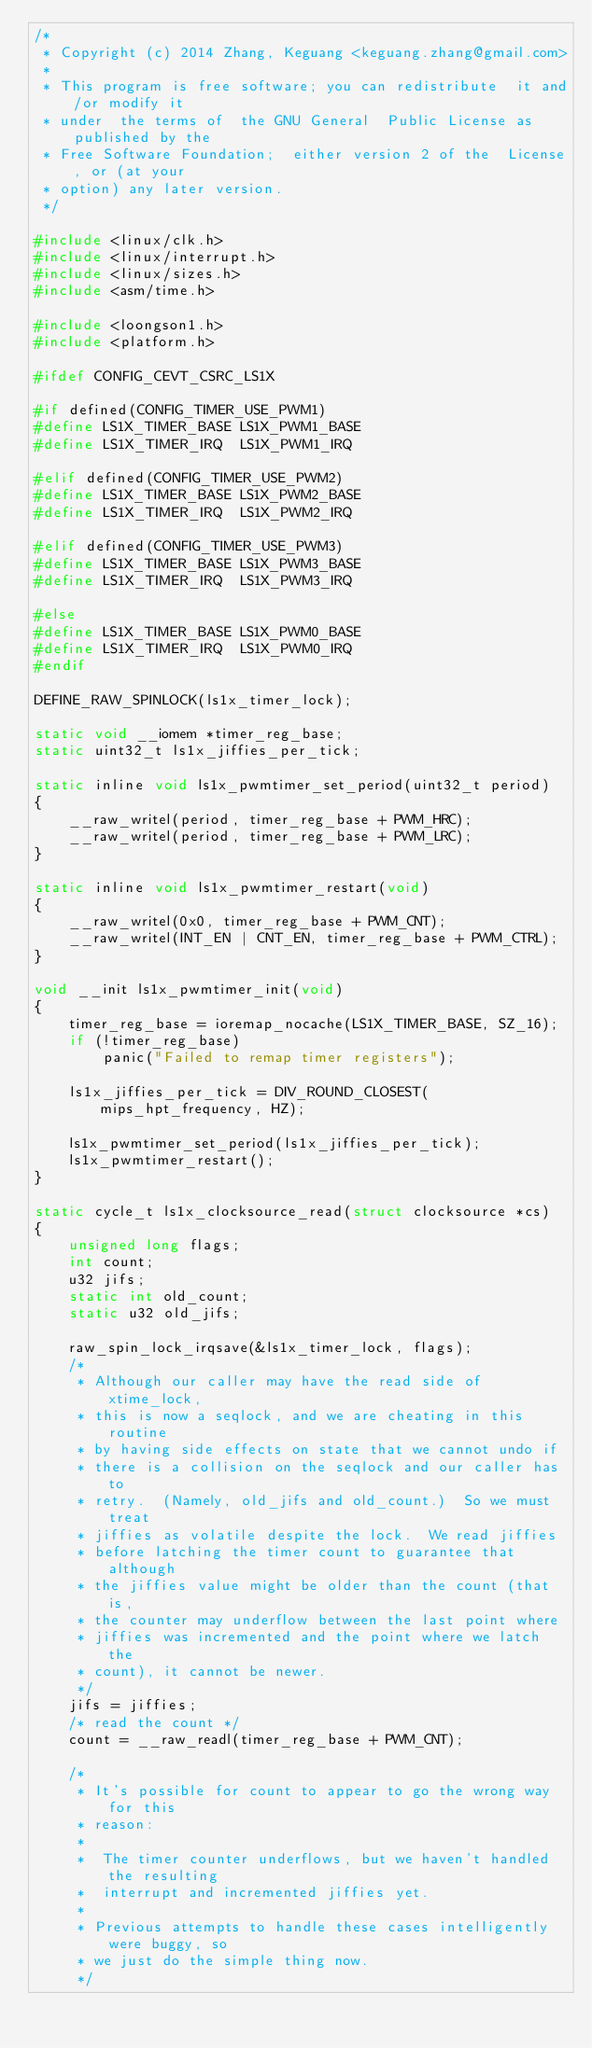Convert code to text. <code><loc_0><loc_0><loc_500><loc_500><_C_>/*
 * Copyright (c) 2014 Zhang, Keguang <keguang.zhang@gmail.com>
 *
 * This program is free software; you can redistribute	it and/or modify it
 * under  the terms of	the GNU General	 Public License as published by the
 * Free Software Foundation;  either version 2 of the  License, or (at your
 * option) any later version.
 */

#include <linux/clk.h>
#include <linux/interrupt.h>
#include <linux/sizes.h>
#include <asm/time.h>

#include <loongson1.h>
#include <platform.h>

#ifdef CONFIG_CEVT_CSRC_LS1X

#if defined(CONFIG_TIMER_USE_PWM1)
#define LS1X_TIMER_BASE	LS1X_PWM1_BASE
#define LS1X_TIMER_IRQ	LS1X_PWM1_IRQ

#elif defined(CONFIG_TIMER_USE_PWM2)
#define LS1X_TIMER_BASE	LS1X_PWM2_BASE
#define LS1X_TIMER_IRQ	LS1X_PWM2_IRQ

#elif defined(CONFIG_TIMER_USE_PWM3)
#define LS1X_TIMER_BASE	LS1X_PWM3_BASE
#define LS1X_TIMER_IRQ	LS1X_PWM3_IRQ

#else
#define LS1X_TIMER_BASE	LS1X_PWM0_BASE
#define LS1X_TIMER_IRQ	LS1X_PWM0_IRQ
#endif

DEFINE_RAW_SPINLOCK(ls1x_timer_lock);

static void __iomem *timer_reg_base;
static uint32_t ls1x_jiffies_per_tick;

static inline void ls1x_pwmtimer_set_period(uint32_t period)
{
	__raw_writel(period, timer_reg_base + PWM_HRC);
	__raw_writel(period, timer_reg_base + PWM_LRC);
}

static inline void ls1x_pwmtimer_restart(void)
{
	__raw_writel(0x0, timer_reg_base + PWM_CNT);
	__raw_writel(INT_EN | CNT_EN, timer_reg_base + PWM_CTRL);
}

void __init ls1x_pwmtimer_init(void)
{
	timer_reg_base = ioremap_nocache(LS1X_TIMER_BASE, SZ_16);
	if (!timer_reg_base)
		panic("Failed to remap timer registers");

	ls1x_jiffies_per_tick = DIV_ROUND_CLOSEST(mips_hpt_frequency, HZ);

	ls1x_pwmtimer_set_period(ls1x_jiffies_per_tick);
	ls1x_pwmtimer_restart();
}

static cycle_t ls1x_clocksource_read(struct clocksource *cs)
{
	unsigned long flags;
	int count;
	u32 jifs;
	static int old_count;
	static u32 old_jifs;

	raw_spin_lock_irqsave(&ls1x_timer_lock, flags);
	/*
	 * Although our caller may have the read side of xtime_lock,
	 * this is now a seqlock, and we are cheating in this routine
	 * by having side effects on state that we cannot undo if
	 * there is a collision on the seqlock and our caller has to
	 * retry.  (Namely, old_jifs and old_count.)  So we must treat
	 * jiffies as volatile despite the lock.  We read jiffies
	 * before latching the timer count to guarantee that although
	 * the jiffies value might be older than the count (that is,
	 * the counter may underflow between the last point where
	 * jiffies was incremented and the point where we latch the
	 * count), it cannot be newer.
	 */
	jifs = jiffies;
	/* read the count */
	count = __raw_readl(timer_reg_base + PWM_CNT);

	/*
	 * It's possible for count to appear to go the wrong way for this
	 * reason:
	 *
	 *  The timer counter underflows, but we haven't handled the resulting
	 *  interrupt and incremented jiffies yet.
	 *
	 * Previous attempts to handle these cases intelligently were buggy, so
	 * we just do the simple thing now.
	 */</code> 